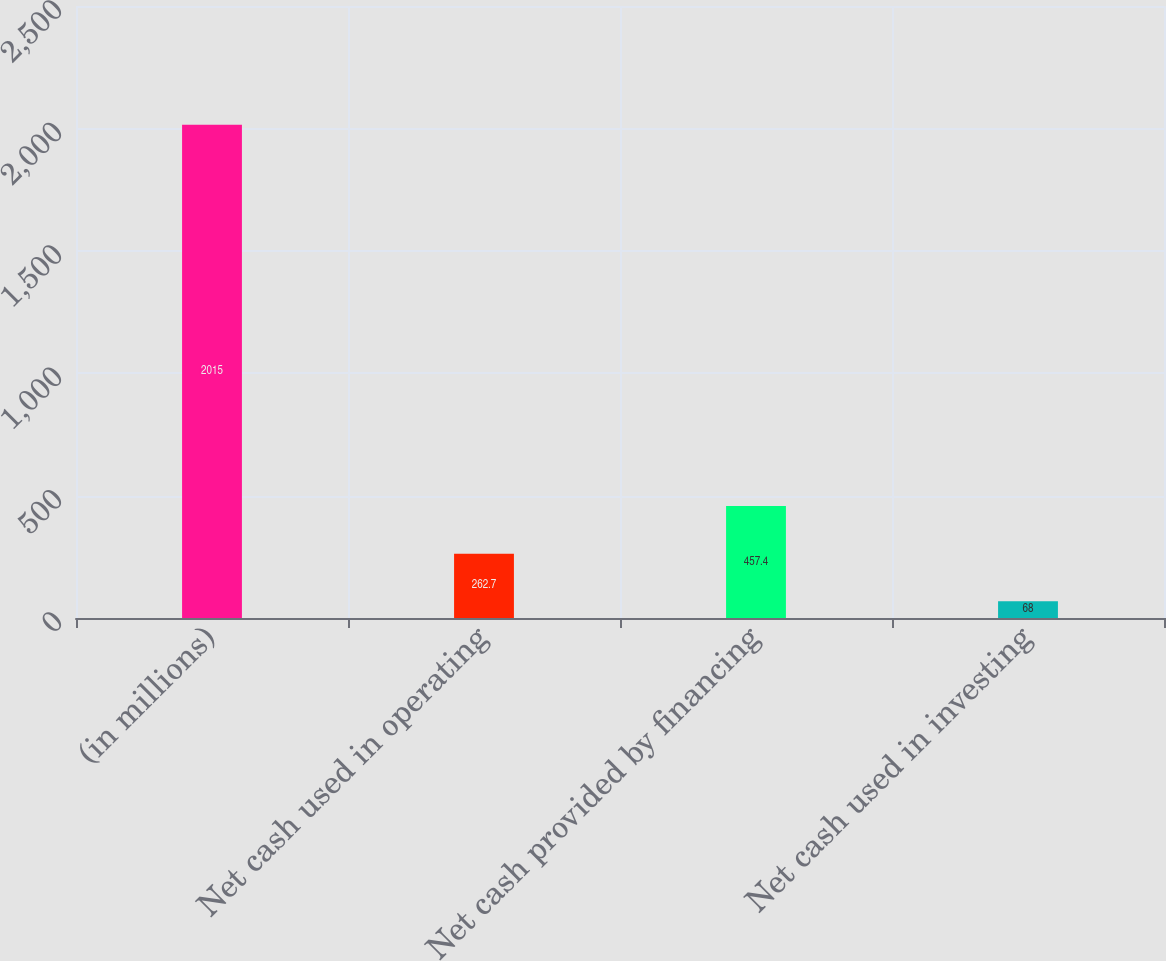<chart> <loc_0><loc_0><loc_500><loc_500><bar_chart><fcel>(in millions)<fcel>Net cash used in operating<fcel>Net cash provided by financing<fcel>Net cash used in investing<nl><fcel>2015<fcel>262.7<fcel>457.4<fcel>68<nl></chart> 